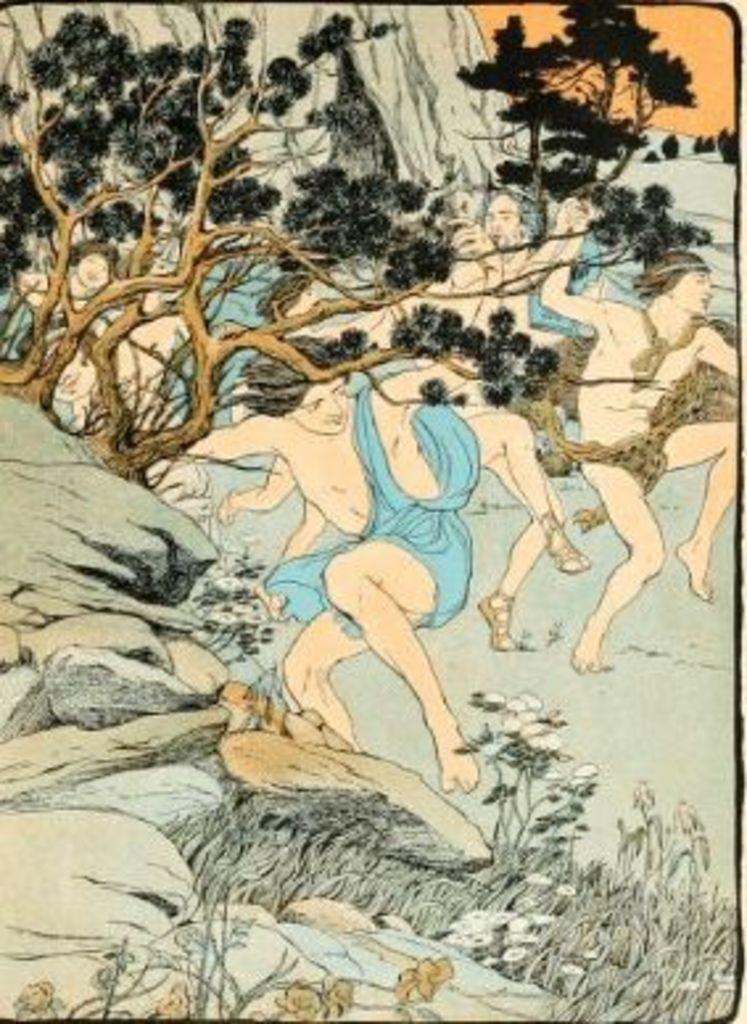Describe this image in one or two sentences. This image is an edited and painting image in which there are persons, trees and stones. 